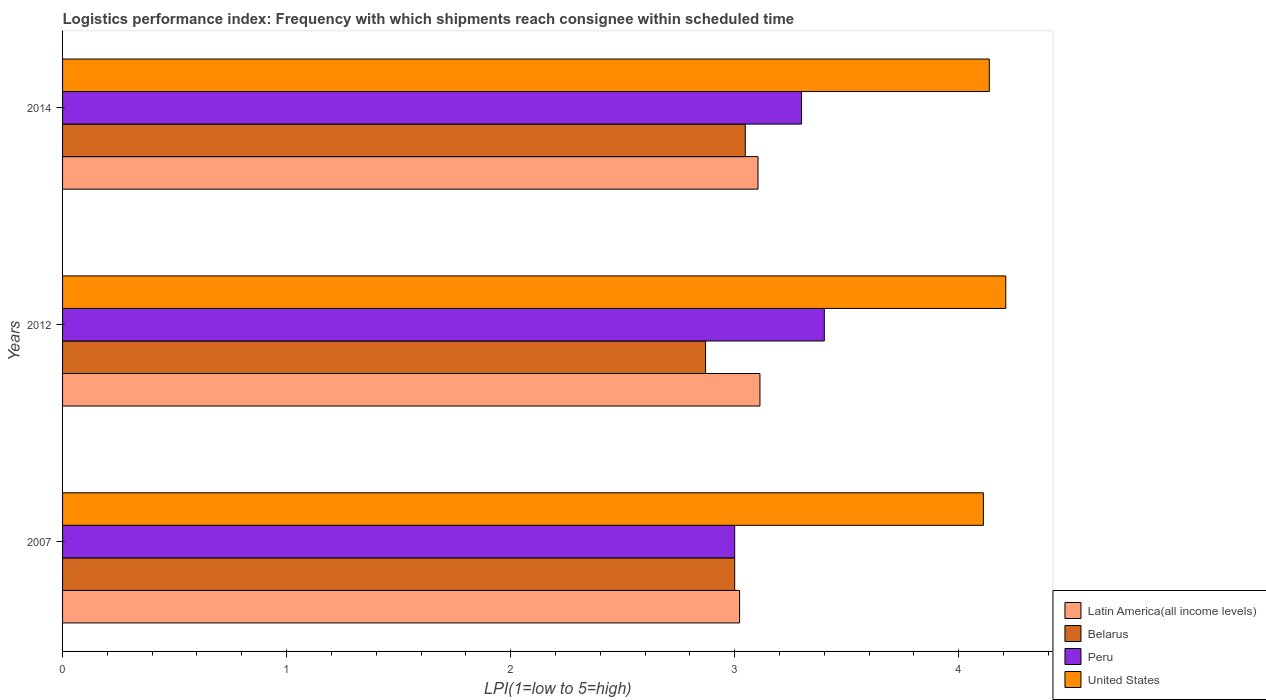How many different coloured bars are there?
Your response must be concise. 4. Are the number of bars per tick equal to the number of legend labels?
Make the answer very short. Yes. Are the number of bars on each tick of the Y-axis equal?
Your answer should be compact. Yes. How many bars are there on the 1st tick from the top?
Your answer should be very brief. 4. In how many cases, is the number of bars for a given year not equal to the number of legend labels?
Make the answer very short. 0. What is the logistics performance index in United States in 2014?
Provide a succinct answer. 4.14. Across all years, what is the minimum logistics performance index in Peru?
Make the answer very short. 3. In which year was the logistics performance index in Peru maximum?
Provide a short and direct response. 2012. In which year was the logistics performance index in Peru minimum?
Your answer should be very brief. 2007. What is the total logistics performance index in United States in the graph?
Offer a very short reply. 12.46. What is the difference between the logistics performance index in Latin America(all income levels) in 2012 and that in 2014?
Your answer should be very brief. 0.01. What is the difference between the logistics performance index in Belarus in 2014 and the logistics performance index in Latin America(all income levels) in 2007?
Your answer should be compact. 0.03. What is the average logistics performance index in Latin America(all income levels) per year?
Your answer should be compact. 3.08. In the year 2007, what is the difference between the logistics performance index in Belarus and logistics performance index in United States?
Your answer should be compact. -1.11. What is the ratio of the logistics performance index in United States in 2007 to that in 2012?
Your response must be concise. 0.98. Is the logistics performance index in Belarus in 2007 less than that in 2012?
Keep it short and to the point. No. What is the difference between the highest and the second highest logistics performance index in Peru?
Your answer should be very brief. 0.1. What is the difference between the highest and the lowest logistics performance index in Latin America(all income levels)?
Ensure brevity in your answer.  0.09. Is it the case that in every year, the sum of the logistics performance index in Belarus and logistics performance index in Peru is greater than the sum of logistics performance index in Latin America(all income levels) and logistics performance index in United States?
Your answer should be compact. No. What does the 4th bar from the top in 2014 represents?
Your answer should be very brief. Latin America(all income levels). How many bars are there?
Your response must be concise. 12. Are all the bars in the graph horizontal?
Keep it short and to the point. Yes. How many years are there in the graph?
Your response must be concise. 3. How many legend labels are there?
Your response must be concise. 4. How are the legend labels stacked?
Your response must be concise. Vertical. What is the title of the graph?
Provide a short and direct response. Logistics performance index: Frequency with which shipments reach consignee within scheduled time. What is the label or title of the X-axis?
Ensure brevity in your answer.  LPI(1=low to 5=high). What is the LPI(1=low to 5=high) of Latin America(all income levels) in 2007?
Your response must be concise. 3.02. What is the LPI(1=low to 5=high) in Belarus in 2007?
Keep it short and to the point. 3. What is the LPI(1=low to 5=high) in Peru in 2007?
Your answer should be compact. 3. What is the LPI(1=low to 5=high) of United States in 2007?
Offer a terse response. 4.11. What is the LPI(1=low to 5=high) of Latin America(all income levels) in 2012?
Your answer should be very brief. 3.11. What is the LPI(1=low to 5=high) of Belarus in 2012?
Your answer should be very brief. 2.87. What is the LPI(1=low to 5=high) of United States in 2012?
Ensure brevity in your answer.  4.21. What is the LPI(1=low to 5=high) in Latin America(all income levels) in 2014?
Your response must be concise. 3.1. What is the LPI(1=low to 5=high) in Belarus in 2014?
Give a very brief answer. 3.05. What is the LPI(1=low to 5=high) of Peru in 2014?
Provide a succinct answer. 3.3. What is the LPI(1=low to 5=high) of United States in 2014?
Offer a very short reply. 4.14. Across all years, what is the maximum LPI(1=low to 5=high) of Latin America(all income levels)?
Give a very brief answer. 3.11. Across all years, what is the maximum LPI(1=low to 5=high) of Belarus?
Your answer should be very brief. 3.05. Across all years, what is the maximum LPI(1=low to 5=high) in United States?
Your response must be concise. 4.21. Across all years, what is the minimum LPI(1=low to 5=high) in Latin America(all income levels)?
Offer a very short reply. 3.02. Across all years, what is the minimum LPI(1=low to 5=high) in Belarus?
Keep it short and to the point. 2.87. Across all years, what is the minimum LPI(1=low to 5=high) of United States?
Your answer should be very brief. 4.11. What is the total LPI(1=low to 5=high) of Latin America(all income levels) in the graph?
Offer a terse response. 9.24. What is the total LPI(1=low to 5=high) in Belarus in the graph?
Provide a succinct answer. 8.92. What is the total LPI(1=low to 5=high) of Peru in the graph?
Your response must be concise. 9.7. What is the total LPI(1=low to 5=high) of United States in the graph?
Give a very brief answer. 12.46. What is the difference between the LPI(1=low to 5=high) in Latin America(all income levels) in 2007 and that in 2012?
Keep it short and to the point. -0.09. What is the difference between the LPI(1=low to 5=high) in Belarus in 2007 and that in 2012?
Your answer should be very brief. 0.13. What is the difference between the LPI(1=low to 5=high) of Peru in 2007 and that in 2012?
Ensure brevity in your answer.  -0.4. What is the difference between the LPI(1=low to 5=high) of United States in 2007 and that in 2012?
Keep it short and to the point. -0.1. What is the difference between the LPI(1=low to 5=high) of Latin America(all income levels) in 2007 and that in 2014?
Give a very brief answer. -0.08. What is the difference between the LPI(1=low to 5=high) of Belarus in 2007 and that in 2014?
Your answer should be compact. -0.05. What is the difference between the LPI(1=low to 5=high) of Peru in 2007 and that in 2014?
Offer a very short reply. -0.3. What is the difference between the LPI(1=low to 5=high) of United States in 2007 and that in 2014?
Provide a short and direct response. -0.03. What is the difference between the LPI(1=low to 5=high) of Latin America(all income levels) in 2012 and that in 2014?
Make the answer very short. 0.01. What is the difference between the LPI(1=low to 5=high) in Belarus in 2012 and that in 2014?
Offer a terse response. -0.18. What is the difference between the LPI(1=low to 5=high) of Peru in 2012 and that in 2014?
Make the answer very short. 0.1. What is the difference between the LPI(1=low to 5=high) in United States in 2012 and that in 2014?
Your answer should be compact. 0.07. What is the difference between the LPI(1=low to 5=high) in Latin America(all income levels) in 2007 and the LPI(1=low to 5=high) in Belarus in 2012?
Give a very brief answer. 0.15. What is the difference between the LPI(1=low to 5=high) of Latin America(all income levels) in 2007 and the LPI(1=low to 5=high) of Peru in 2012?
Give a very brief answer. -0.38. What is the difference between the LPI(1=low to 5=high) in Latin America(all income levels) in 2007 and the LPI(1=low to 5=high) in United States in 2012?
Provide a succinct answer. -1.19. What is the difference between the LPI(1=low to 5=high) of Belarus in 2007 and the LPI(1=low to 5=high) of Peru in 2012?
Provide a succinct answer. -0.4. What is the difference between the LPI(1=low to 5=high) of Belarus in 2007 and the LPI(1=low to 5=high) of United States in 2012?
Make the answer very short. -1.21. What is the difference between the LPI(1=low to 5=high) of Peru in 2007 and the LPI(1=low to 5=high) of United States in 2012?
Your answer should be very brief. -1.21. What is the difference between the LPI(1=low to 5=high) in Latin America(all income levels) in 2007 and the LPI(1=low to 5=high) in Belarus in 2014?
Your answer should be very brief. -0.03. What is the difference between the LPI(1=low to 5=high) of Latin America(all income levels) in 2007 and the LPI(1=low to 5=high) of Peru in 2014?
Ensure brevity in your answer.  -0.28. What is the difference between the LPI(1=low to 5=high) of Latin America(all income levels) in 2007 and the LPI(1=low to 5=high) of United States in 2014?
Your response must be concise. -1.11. What is the difference between the LPI(1=low to 5=high) in Belarus in 2007 and the LPI(1=low to 5=high) in Peru in 2014?
Keep it short and to the point. -0.3. What is the difference between the LPI(1=low to 5=high) of Belarus in 2007 and the LPI(1=low to 5=high) of United States in 2014?
Make the answer very short. -1.14. What is the difference between the LPI(1=low to 5=high) of Peru in 2007 and the LPI(1=low to 5=high) of United States in 2014?
Give a very brief answer. -1.14. What is the difference between the LPI(1=low to 5=high) in Latin America(all income levels) in 2012 and the LPI(1=low to 5=high) in Belarus in 2014?
Your response must be concise. 0.07. What is the difference between the LPI(1=low to 5=high) in Latin America(all income levels) in 2012 and the LPI(1=low to 5=high) in Peru in 2014?
Provide a succinct answer. -0.19. What is the difference between the LPI(1=low to 5=high) in Latin America(all income levels) in 2012 and the LPI(1=low to 5=high) in United States in 2014?
Provide a succinct answer. -1.02. What is the difference between the LPI(1=low to 5=high) in Belarus in 2012 and the LPI(1=low to 5=high) in Peru in 2014?
Provide a short and direct response. -0.43. What is the difference between the LPI(1=low to 5=high) of Belarus in 2012 and the LPI(1=low to 5=high) of United States in 2014?
Provide a succinct answer. -1.27. What is the difference between the LPI(1=low to 5=high) in Peru in 2012 and the LPI(1=low to 5=high) in United States in 2014?
Your response must be concise. -0.74. What is the average LPI(1=low to 5=high) of Latin America(all income levels) per year?
Keep it short and to the point. 3.08. What is the average LPI(1=low to 5=high) in Belarus per year?
Provide a short and direct response. 2.97. What is the average LPI(1=low to 5=high) of Peru per year?
Provide a succinct answer. 3.23. What is the average LPI(1=low to 5=high) of United States per year?
Your response must be concise. 4.15. In the year 2007, what is the difference between the LPI(1=low to 5=high) of Latin America(all income levels) and LPI(1=low to 5=high) of Belarus?
Your response must be concise. 0.02. In the year 2007, what is the difference between the LPI(1=low to 5=high) in Latin America(all income levels) and LPI(1=low to 5=high) in Peru?
Provide a succinct answer. 0.02. In the year 2007, what is the difference between the LPI(1=low to 5=high) of Latin America(all income levels) and LPI(1=low to 5=high) of United States?
Give a very brief answer. -1.09. In the year 2007, what is the difference between the LPI(1=low to 5=high) in Belarus and LPI(1=low to 5=high) in Peru?
Offer a very short reply. 0. In the year 2007, what is the difference between the LPI(1=low to 5=high) of Belarus and LPI(1=low to 5=high) of United States?
Offer a very short reply. -1.11. In the year 2007, what is the difference between the LPI(1=low to 5=high) of Peru and LPI(1=low to 5=high) of United States?
Keep it short and to the point. -1.11. In the year 2012, what is the difference between the LPI(1=low to 5=high) of Latin America(all income levels) and LPI(1=low to 5=high) of Belarus?
Keep it short and to the point. 0.24. In the year 2012, what is the difference between the LPI(1=low to 5=high) in Latin America(all income levels) and LPI(1=low to 5=high) in Peru?
Your answer should be very brief. -0.29. In the year 2012, what is the difference between the LPI(1=low to 5=high) of Latin America(all income levels) and LPI(1=low to 5=high) of United States?
Ensure brevity in your answer.  -1.1. In the year 2012, what is the difference between the LPI(1=low to 5=high) in Belarus and LPI(1=low to 5=high) in Peru?
Provide a succinct answer. -0.53. In the year 2012, what is the difference between the LPI(1=low to 5=high) in Belarus and LPI(1=low to 5=high) in United States?
Keep it short and to the point. -1.34. In the year 2012, what is the difference between the LPI(1=low to 5=high) of Peru and LPI(1=low to 5=high) of United States?
Keep it short and to the point. -0.81. In the year 2014, what is the difference between the LPI(1=low to 5=high) in Latin America(all income levels) and LPI(1=low to 5=high) in Belarus?
Make the answer very short. 0.06. In the year 2014, what is the difference between the LPI(1=low to 5=high) of Latin America(all income levels) and LPI(1=low to 5=high) of Peru?
Ensure brevity in your answer.  -0.19. In the year 2014, what is the difference between the LPI(1=low to 5=high) in Latin America(all income levels) and LPI(1=low to 5=high) in United States?
Ensure brevity in your answer.  -1.03. In the year 2014, what is the difference between the LPI(1=low to 5=high) of Belarus and LPI(1=low to 5=high) of Peru?
Give a very brief answer. -0.25. In the year 2014, what is the difference between the LPI(1=low to 5=high) in Belarus and LPI(1=low to 5=high) in United States?
Make the answer very short. -1.09. In the year 2014, what is the difference between the LPI(1=low to 5=high) in Peru and LPI(1=low to 5=high) in United States?
Your answer should be very brief. -0.84. What is the ratio of the LPI(1=low to 5=high) of Latin America(all income levels) in 2007 to that in 2012?
Ensure brevity in your answer.  0.97. What is the ratio of the LPI(1=low to 5=high) of Belarus in 2007 to that in 2012?
Keep it short and to the point. 1.05. What is the ratio of the LPI(1=low to 5=high) of Peru in 2007 to that in 2012?
Provide a succinct answer. 0.88. What is the ratio of the LPI(1=low to 5=high) of United States in 2007 to that in 2012?
Your answer should be compact. 0.98. What is the ratio of the LPI(1=low to 5=high) in Latin America(all income levels) in 2007 to that in 2014?
Give a very brief answer. 0.97. What is the ratio of the LPI(1=low to 5=high) in Belarus in 2007 to that in 2014?
Offer a terse response. 0.98. What is the ratio of the LPI(1=low to 5=high) in Peru in 2007 to that in 2014?
Make the answer very short. 0.91. What is the ratio of the LPI(1=low to 5=high) in United States in 2007 to that in 2014?
Provide a succinct answer. 0.99. What is the ratio of the LPI(1=low to 5=high) of Belarus in 2012 to that in 2014?
Ensure brevity in your answer.  0.94. What is the ratio of the LPI(1=low to 5=high) of Peru in 2012 to that in 2014?
Your response must be concise. 1.03. What is the ratio of the LPI(1=low to 5=high) of United States in 2012 to that in 2014?
Your response must be concise. 1.02. What is the difference between the highest and the second highest LPI(1=low to 5=high) of Latin America(all income levels)?
Make the answer very short. 0.01. What is the difference between the highest and the second highest LPI(1=low to 5=high) in Belarus?
Keep it short and to the point. 0.05. What is the difference between the highest and the second highest LPI(1=low to 5=high) in Peru?
Make the answer very short. 0.1. What is the difference between the highest and the second highest LPI(1=low to 5=high) in United States?
Your answer should be compact. 0.07. What is the difference between the highest and the lowest LPI(1=low to 5=high) in Latin America(all income levels)?
Offer a very short reply. 0.09. What is the difference between the highest and the lowest LPI(1=low to 5=high) of Belarus?
Keep it short and to the point. 0.18. What is the difference between the highest and the lowest LPI(1=low to 5=high) of Peru?
Offer a very short reply. 0.4. 